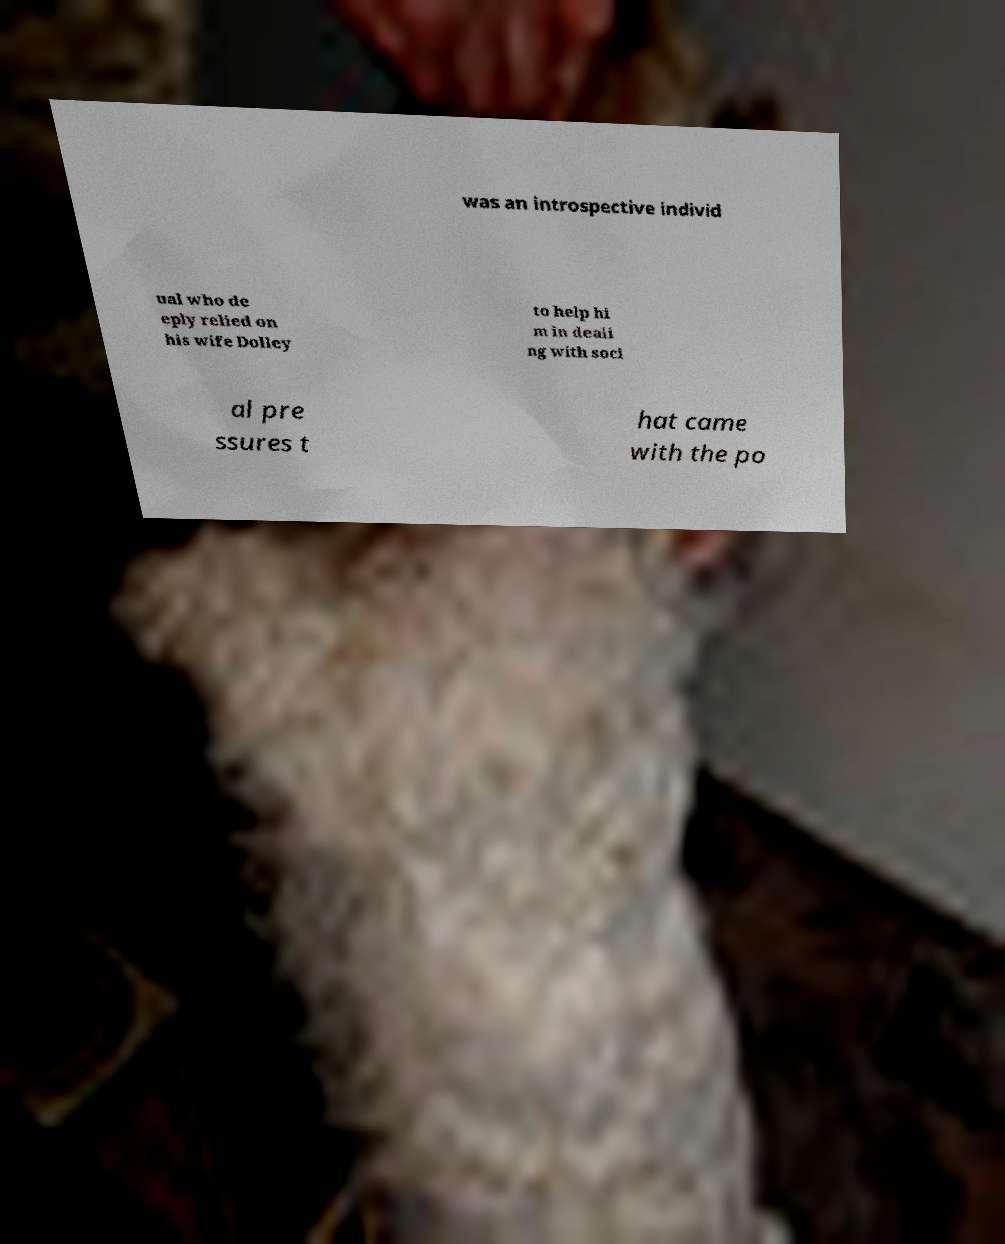Please identify and transcribe the text found in this image. was an introspective individ ual who de eply relied on his wife Dolley to help hi m in deali ng with soci al pre ssures t hat came with the po 